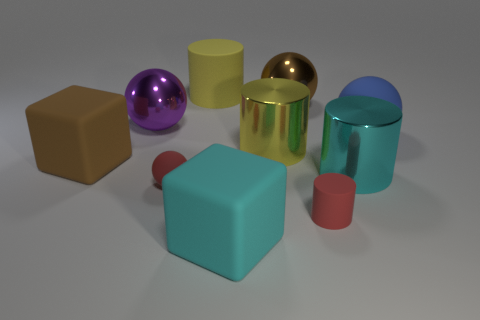Subtract all balls. How many objects are left? 6 Subtract all small matte cylinders. Subtract all large cyan cubes. How many objects are left? 8 Add 2 red cylinders. How many red cylinders are left? 3 Add 7 brown matte blocks. How many brown matte blocks exist? 8 Subtract 0 red cubes. How many objects are left? 10 